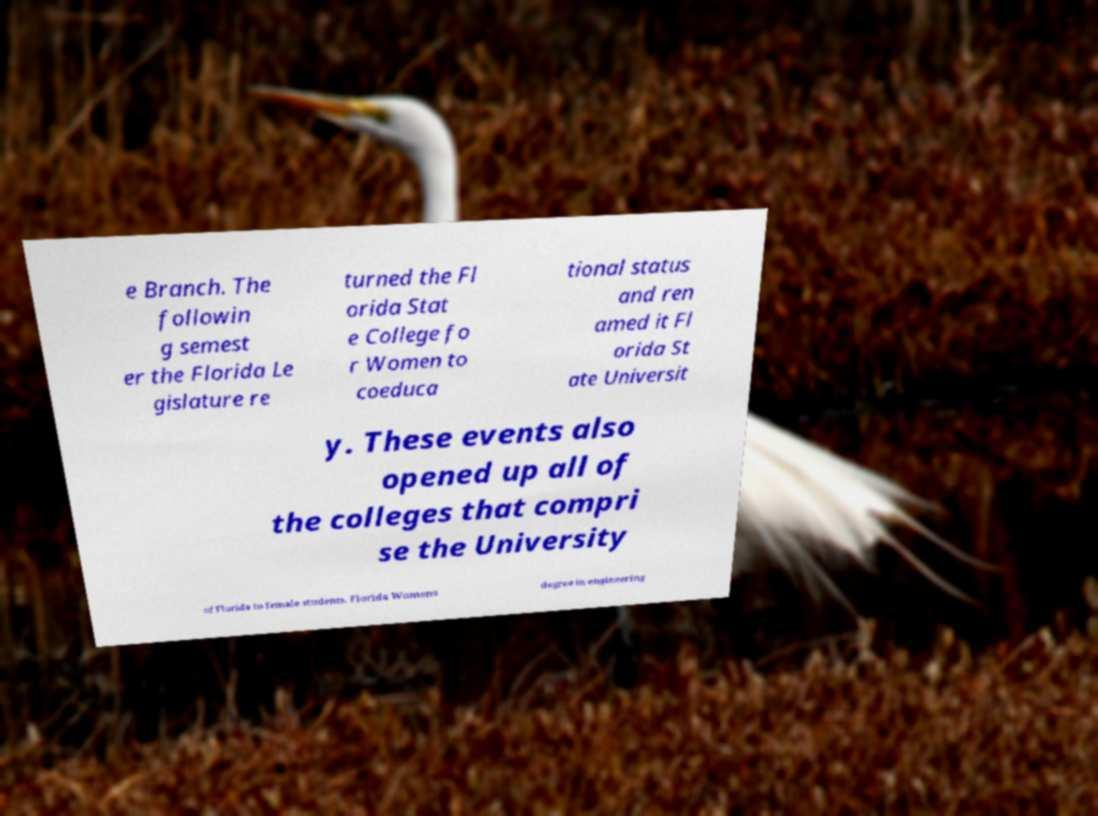Can you read and provide the text displayed in the image?This photo seems to have some interesting text. Can you extract and type it out for me? e Branch. The followin g semest er the Florida Le gislature re turned the Fl orida Stat e College fo r Women to coeduca tional status and ren amed it Fl orida St ate Universit y. These events also opened up all of the colleges that compri se the University of Florida to female students. Florida Womens degree in engineering 